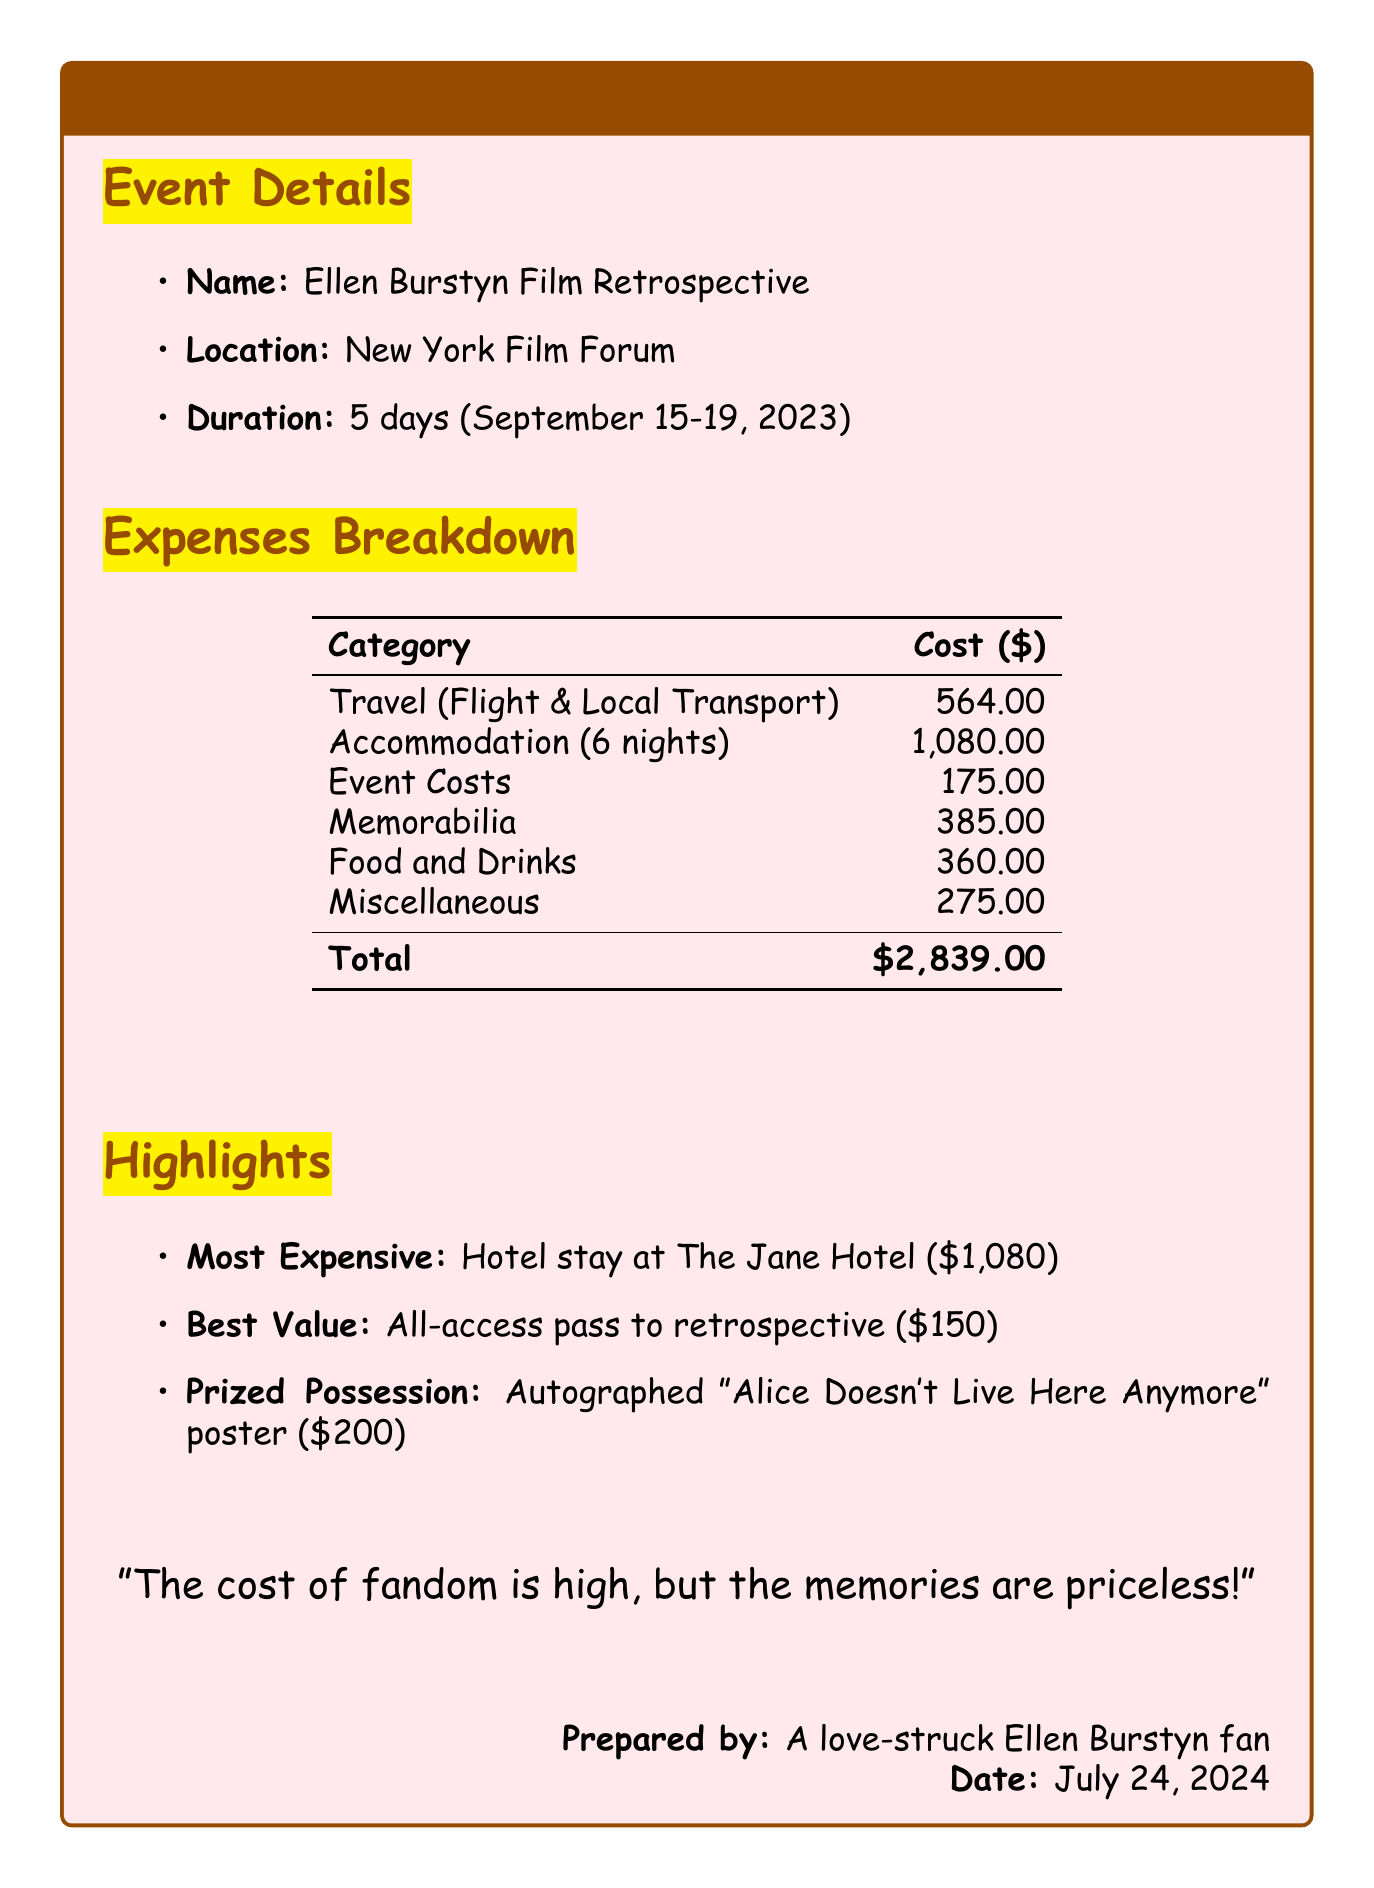What is the total cost of travel expenses? The total cost of travel expenses includes flight and local transportation costs, totaling $564.00.
Answer: $564.00 Where is the event being held? The event is being held at the New York Film Forum.
Answer: New York Film Forum How many nights was the accommodation booked for? The document states that the accommodation was booked for 6 nights.
Answer: 6 nights What category has the highest expense? The highest expense category is accommodation, which cost $1,080.00.
Answer: Accommodation What is the cost of the all-access pass? The cost of the all-access pass for the event is detailed in the document as $150.00.
Answer: $150.00 How much was spent on memorabilia? The total spent on memorabilia is the sum of individual items which adds up to $385.00.
Answer: $385.00 What is the total budget for food and drinks? The total budget for food and drinks for the trip is specified as $360.00.
Answer: $360.00 What is the duration of the film retrospective? The duration of the film retrospective is given as 5 days.
Answer: 5 days What is the total amount spent on miscellaneous expenses? The document lists miscellaneous expenses totaling $275.00.
Answer: $275.00 